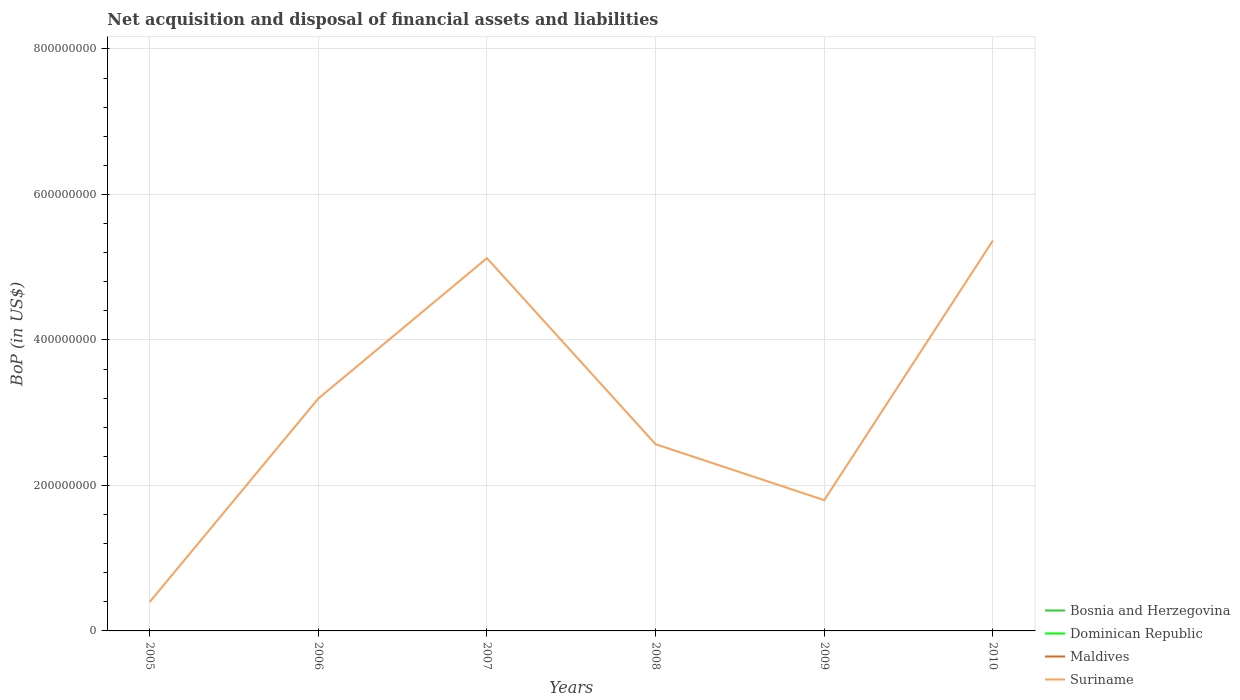Does the line corresponding to Maldives intersect with the line corresponding to Dominican Republic?
Your answer should be compact. No. Is the number of lines equal to the number of legend labels?
Offer a terse response. No. Across all years, what is the maximum Balance of Payments in Bosnia and Herzegovina?
Give a very brief answer. 0. What is the total Balance of Payments in Suriname in the graph?
Your response must be concise. -2.80e+08. What is the difference between the highest and the second highest Balance of Payments in Suriname?
Your answer should be very brief. 4.97e+08. What is the difference between the highest and the lowest Balance of Payments in Dominican Republic?
Your answer should be compact. 0. How many lines are there?
Keep it short and to the point. 1. How many years are there in the graph?
Keep it short and to the point. 6. Where does the legend appear in the graph?
Provide a succinct answer. Bottom right. What is the title of the graph?
Your answer should be very brief. Net acquisition and disposal of financial assets and liabilities. Does "Italy" appear as one of the legend labels in the graph?
Ensure brevity in your answer.  No. What is the label or title of the Y-axis?
Ensure brevity in your answer.  BoP (in US$). What is the BoP (in US$) in Maldives in 2005?
Provide a short and direct response. 0. What is the BoP (in US$) in Suriname in 2005?
Your answer should be compact. 3.97e+07. What is the BoP (in US$) in Bosnia and Herzegovina in 2006?
Give a very brief answer. 0. What is the BoP (in US$) in Maldives in 2006?
Ensure brevity in your answer.  0. What is the BoP (in US$) in Suriname in 2006?
Keep it short and to the point. 3.19e+08. What is the BoP (in US$) of Bosnia and Herzegovina in 2007?
Provide a succinct answer. 0. What is the BoP (in US$) of Dominican Republic in 2007?
Offer a terse response. 0. What is the BoP (in US$) of Suriname in 2007?
Give a very brief answer. 5.12e+08. What is the BoP (in US$) of Dominican Republic in 2008?
Keep it short and to the point. 0. What is the BoP (in US$) of Maldives in 2008?
Your response must be concise. 0. What is the BoP (in US$) of Suriname in 2008?
Your answer should be compact. 2.57e+08. What is the BoP (in US$) in Dominican Republic in 2009?
Your answer should be very brief. 0. What is the BoP (in US$) in Suriname in 2009?
Provide a succinct answer. 1.80e+08. What is the BoP (in US$) in Dominican Republic in 2010?
Provide a short and direct response. 0. What is the BoP (in US$) of Maldives in 2010?
Provide a short and direct response. 0. What is the BoP (in US$) in Suriname in 2010?
Offer a terse response. 5.37e+08. Across all years, what is the maximum BoP (in US$) of Suriname?
Provide a succinct answer. 5.37e+08. Across all years, what is the minimum BoP (in US$) in Suriname?
Offer a very short reply. 3.97e+07. What is the total BoP (in US$) of Dominican Republic in the graph?
Provide a succinct answer. 0. What is the total BoP (in US$) of Maldives in the graph?
Offer a very short reply. 0. What is the total BoP (in US$) in Suriname in the graph?
Make the answer very short. 1.84e+09. What is the difference between the BoP (in US$) of Suriname in 2005 and that in 2006?
Keep it short and to the point. -2.80e+08. What is the difference between the BoP (in US$) of Suriname in 2005 and that in 2007?
Make the answer very short. -4.73e+08. What is the difference between the BoP (in US$) of Suriname in 2005 and that in 2008?
Ensure brevity in your answer.  -2.17e+08. What is the difference between the BoP (in US$) in Suriname in 2005 and that in 2009?
Offer a very short reply. -1.40e+08. What is the difference between the BoP (in US$) of Suriname in 2005 and that in 2010?
Your answer should be very brief. -4.97e+08. What is the difference between the BoP (in US$) in Suriname in 2006 and that in 2007?
Make the answer very short. -1.93e+08. What is the difference between the BoP (in US$) in Suriname in 2006 and that in 2008?
Ensure brevity in your answer.  6.28e+07. What is the difference between the BoP (in US$) in Suriname in 2006 and that in 2009?
Offer a very short reply. 1.40e+08. What is the difference between the BoP (in US$) in Suriname in 2006 and that in 2010?
Keep it short and to the point. -2.17e+08. What is the difference between the BoP (in US$) in Suriname in 2007 and that in 2008?
Your answer should be very brief. 2.56e+08. What is the difference between the BoP (in US$) of Suriname in 2007 and that in 2009?
Ensure brevity in your answer.  3.33e+08. What is the difference between the BoP (in US$) of Suriname in 2007 and that in 2010?
Your response must be concise. -2.42e+07. What is the difference between the BoP (in US$) in Suriname in 2008 and that in 2009?
Offer a very short reply. 7.69e+07. What is the difference between the BoP (in US$) in Suriname in 2008 and that in 2010?
Offer a very short reply. -2.80e+08. What is the difference between the BoP (in US$) in Suriname in 2009 and that in 2010?
Offer a terse response. -3.57e+08. What is the average BoP (in US$) of Suriname per year?
Offer a terse response. 3.07e+08. What is the ratio of the BoP (in US$) of Suriname in 2005 to that in 2006?
Your answer should be very brief. 0.12. What is the ratio of the BoP (in US$) in Suriname in 2005 to that in 2007?
Ensure brevity in your answer.  0.08. What is the ratio of the BoP (in US$) in Suriname in 2005 to that in 2008?
Keep it short and to the point. 0.15. What is the ratio of the BoP (in US$) in Suriname in 2005 to that in 2009?
Your answer should be very brief. 0.22. What is the ratio of the BoP (in US$) in Suriname in 2005 to that in 2010?
Make the answer very short. 0.07. What is the ratio of the BoP (in US$) of Suriname in 2006 to that in 2007?
Keep it short and to the point. 0.62. What is the ratio of the BoP (in US$) in Suriname in 2006 to that in 2008?
Keep it short and to the point. 1.24. What is the ratio of the BoP (in US$) of Suriname in 2006 to that in 2009?
Make the answer very short. 1.78. What is the ratio of the BoP (in US$) of Suriname in 2006 to that in 2010?
Your answer should be compact. 0.6. What is the ratio of the BoP (in US$) in Suriname in 2007 to that in 2008?
Ensure brevity in your answer.  2. What is the ratio of the BoP (in US$) in Suriname in 2007 to that in 2009?
Make the answer very short. 2.85. What is the ratio of the BoP (in US$) of Suriname in 2007 to that in 2010?
Your answer should be very brief. 0.95. What is the ratio of the BoP (in US$) in Suriname in 2008 to that in 2009?
Provide a short and direct response. 1.43. What is the ratio of the BoP (in US$) of Suriname in 2008 to that in 2010?
Your response must be concise. 0.48. What is the ratio of the BoP (in US$) of Suriname in 2009 to that in 2010?
Your answer should be compact. 0.34. What is the difference between the highest and the second highest BoP (in US$) in Suriname?
Provide a short and direct response. 2.42e+07. What is the difference between the highest and the lowest BoP (in US$) of Suriname?
Offer a terse response. 4.97e+08. 